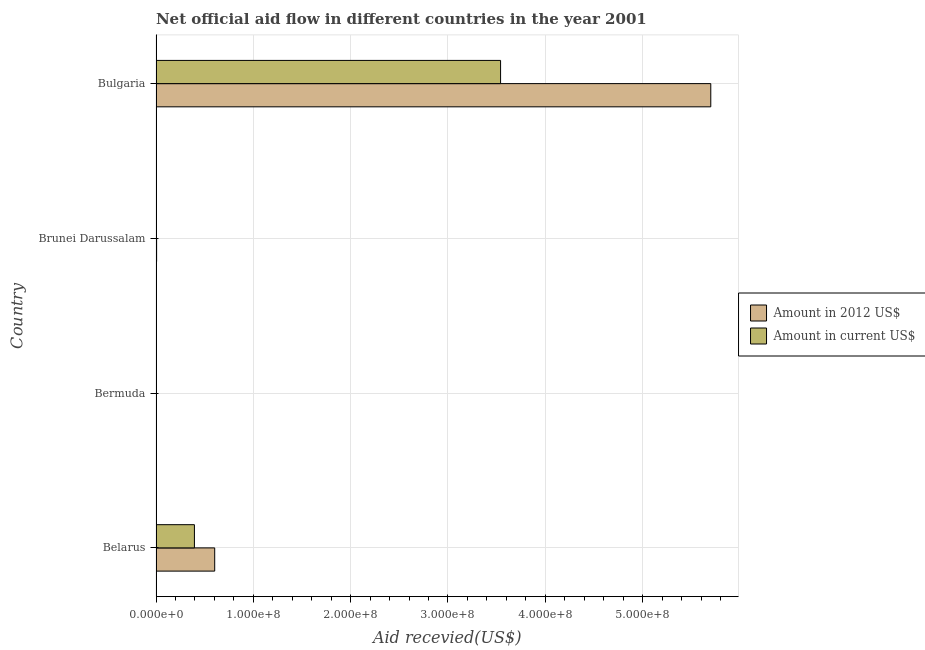How many different coloured bars are there?
Your response must be concise. 2. Are the number of bars per tick equal to the number of legend labels?
Make the answer very short. Yes. Are the number of bars on each tick of the Y-axis equal?
Offer a very short reply. Yes. How many bars are there on the 3rd tick from the top?
Your response must be concise. 2. How many bars are there on the 2nd tick from the bottom?
Ensure brevity in your answer.  2. What is the label of the 3rd group of bars from the top?
Your answer should be very brief. Bermuda. In how many cases, is the number of bars for a given country not equal to the number of legend labels?
Ensure brevity in your answer.  0. What is the amount of aid received(expressed in us$) in Brunei Darussalam?
Your answer should be compact. 3.50e+05. Across all countries, what is the maximum amount of aid received(expressed in 2012 us$)?
Ensure brevity in your answer.  5.70e+08. Across all countries, what is the minimum amount of aid received(expressed in 2012 us$)?
Give a very brief answer. 4.00e+04. In which country was the amount of aid received(expressed in us$) maximum?
Your response must be concise. Bulgaria. In which country was the amount of aid received(expressed in 2012 us$) minimum?
Offer a terse response. Bermuda. What is the total amount of aid received(expressed in us$) in the graph?
Provide a short and direct response. 3.94e+08. What is the difference between the amount of aid received(expressed in 2012 us$) in Bermuda and that in Brunei Darussalam?
Provide a short and direct response. -5.60e+05. What is the difference between the amount of aid received(expressed in us$) in Bermuda and the amount of aid received(expressed in 2012 us$) in Brunei Darussalam?
Make the answer very short. -5.80e+05. What is the average amount of aid received(expressed in 2012 us$) per country?
Make the answer very short. 1.58e+08. What is the difference between the amount of aid received(expressed in us$) and amount of aid received(expressed in 2012 us$) in Bermuda?
Provide a short and direct response. -2.00e+04. Is the amount of aid received(expressed in us$) in Bermuda less than that in Brunei Darussalam?
Ensure brevity in your answer.  Yes. Is the difference between the amount of aid received(expressed in us$) in Belarus and Bermuda greater than the difference between the amount of aid received(expressed in 2012 us$) in Belarus and Bermuda?
Keep it short and to the point. No. What is the difference between the highest and the second highest amount of aid received(expressed in us$)?
Your answer should be compact. 3.15e+08. What is the difference between the highest and the lowest amount of aid received(expressed in us$)?
Ensure brevity in your answer.  3.54e+08. In how many countries, is the amount of aid received(expressed in 2012 us$) greater than the average amount of aid received(expressed in 2012 us$) taken over all countries?
Give a very brief answer. 1. What does the 1st bar from the top in Belarus represents?
Ensure brevity in your answer.  Amount in current US$. What does the 2nd bar from the bottom in Brunei Darussalam represents?
Ensure brevity in your answer.  Amount in current US$. Are all the bars in the graph horizontal?
Offer a very short reply. Yes. What is the difference between two consecutive major ticks on the X-axis?
Your answer should be compact. 1.00e+08. Are the values on the major ticks of X-axis written in scientific E-notation?
Make the answer very short. Yes. Does the graph contain any zero values?
Offer a terse response. No. Where does the legend appear in the graph?
Ensure brevity in your answer.  Center right. How are the legend labels stacked?
Provide a succinct answer. Vertical. What is the title of the graph?
Your answer should be very brief. Net official aid flow in different countries in the year 2001. Does "Food and tobacco" appear as one of the legend labels in the graph?
Offer a very short reply. No. What is the label or title of the X-axis?
Your response must be concise. Aid recevied(US$). What is the label or title of the Y-axis?
Your answer should be compact. Country. What is the Aid recevied(US$) of Amount in 2012 US$ in Belarus?
Ensure brevity in your answer.  6.03e+07. What is the Aid recevied(US$) in Amount in current US$ in Belarus?
Offer a very short reply. 3.94e+07. What is the Aid recevied(US$) in Amount in current US$ in Bermuda?
Your answer should be very brief. 2.00e+04. What is the Aid recevied(US$) in Amount in 2012 US$ in Bulgaria?
Your answer should be very brief. 5.70e+08. What is the Aid recevied(US$) in Amount in current US$ in Bulgaria?
Provide a short and direct response. 3.54e+08. Across all countries, what is the maximum Aid recevied(US$) of Amount in 2012 US$?
Offer a terse response. 5.70e+08. Across all countries, what is the maximum Aid recevied(US$) in Amount in current US$?
Offer a terse response. 3.54e+08. What is the total Aid recevied(US$) of Amount in 2012 US$ in the graph?
Offer a very short reply. 6.31e+08. What is the total Aid recevied(US$) in Amount in current US$ in the graph?
Your response must be concise. 3.94e+08. What is the difference between the Aid recevied(US$) in Amount in 2012 US$ in Belarus and that in Bermuda?
Your answer should be compact. 6.02e+07. What is the difference between the Aid recevied(US$) of Amount in current US$ in Belarus and that in Bermuda?
Ensure brevity in your answer.  3.94e+07. What is the difference between the Aid recevied(US$) of Amount in 2012 US$ in Belarus and that in Brunei Darussalam?
Give a very brief answer. 5.97e+07. What is the difference between the Aid recevied(US$) of Amount in current US$ in Belarus and that in Brunei Darussalam?
Your answer should be very brief. 3.91e+07. What is the difference between the Aid recevied(US$) in Amount in 2012 US$ in Belarus and that in Bulgaria?
Provide a short and direct response. -5.10e+08. What is the difference between the Aid recevied(US$) in Amount in current US$ in Belarus and that in Bulgaria?
Provide a short and direct response. -3.15e+08. What is the difference between the Aid recevied(US$) in Amount in 2012 US$ in Bermuda and that in Brunei Darussalam?
Your answer should be very brief. -5.60e+05. What is the difference between the Aid recevied(US$) of Amount in current US$ in Bermuda and that in Brunei Darussalam?
Make the answer very short. -3.30e+05. What is the difference between the Aid recevied(US$) of Amount in 2012 US$ in Bermuda and that in Bulgaria?
Your answer should be compact. -5.70e+08. What is the difference between the Aid recevied(US$) of Amount in current US$ in Bermuda and that in Bulgaria?
Provide a short and direct response. -3.54e+08. What is the difference between the Aid recevied(US$) in Amount in 2012 US$ in Brunei Darussalam and that in Bulgaria?
Provide a succinct answer. -5.69e+08. What is the difference between the Aid recevied(US$) in Amount in current US$ in Brunei Darussalam and that in Bulgaria?
Ensure brevity in your answer.  -3.54e+08. What is the difference between the Aid recevied(US$) in Amount in 2012 US$ in Belarus and the Aid recevied(US$) in Amount in current US$ in Bermuda?
Give a very brief answer. 6.03e+07. What is the difference between the Aid recevied(US$) of Amount in 2012 US$ in Belarus and the Aid recevied(US$) of Amount in current US$ in Brunei Darussalam?
Your answer should be compact. 5.99e+07. What is the difference between the Aid recevied(US$) in Amount in 2012 US$ in Belarus and the Aid recevied(US$) in Amount in current US$ in Bulgaria?
Your answer should be compact. -2.94e+08. What is the difference between the Aid recevied(US$) of Amount in 2012 US$ in Bermuda and the Aid recevied(US$) of Amount in current US$ in Brunei Darussalam?
Make the answer very short. -3.10e+05. What is the difference between the Aid recevied(US$) in Amount in 2012 US$ in Bermuda and the Aid recevied(US$) in Amount in current US$ in Bulgaria?
Your response must be concise. -3.54e+08. What is the difference between the Aid recevied(US$) in Amount in 2012 US$ in Brunei Darussalam and the Aid recevied(US$) in Amount in current US$ in Bulgaria?
Keep it short and to the point. -3.53e+08. What is the average Aid recevied(US$) in Amount in 2012 US$ per country?
Make the answer very short. 1.58e+08. What is the average Aid recevied(US$) in Amount in current US$ per country?
Offer a terse response. 9.85e+07. What is the difference between the Aid recevied(US$) of Amount in 2012 US$ and Aid recevied(US$) of Amount in current US$ in Belarus?
Provide a succinct answer. 2.08e+07. What is the difference between the Aid recevied(US$) in Amount in 2012 US$ and Aid recevied(US$) in Amount in current US$ in Bermuda?
Offer a very short reply. 2.00e+04. What is the difference between the Aid recevied(US$) in Amount in 2012 US$ and Aid recevied(US$) in Amount in current US$ in Bulgaria?
Your response must be concise. 2.16e+08. What is the ratio of the Aid recevied(US$) in Amount in 2012 US$ in Belarus to that in Bermuda?
Provide a short and direct response. 1507.25. What is the ratio of the Aid recevied(US$) in Amount in current US$ in Belarus to that in Bermuda?
Your response must be concise. 1972.5. What is the ratio of the Aid recevied(US$) of Amount in 2012 US$ in Belarus to that in Brunei Darussalam?
Your answer should be compact. 100.48. What is the ratio of the Aid recevied(US$) in Amount in current US$ in Belarus to that in Brunei Darussalam?
Make the answer very short. 112.71. What is the ratio of the Aid recevied(US$) of Amount in 2012 US$ in Belarus to that in Bulgaria?
Provide a succinct answer. 0.11. What is the ratio of the Aid recevied(US$) in Amount in current US$ in Belarus to that in Bulgaria?
Keep it short and to the point. 0.11. What is the ratio of the Aid recevied(US$) in Amount in 2012 US$ in Bermuda to that in Brunei Darussalam?
Ensure brevity in your answer.  0.07. What is the ratio of the Aid recevied(US$) of Amount in current US$ in Bermuda to that in Brunei Darussalam?
Provide a short and direct response. 0.06. What is the ratio of the Aid recevied(US$) in Amount in 2012 US$ in Bermuda to that in Bulgaria?
Provide a succinct answer. 0. What is the ratio of the Aid recevied(US$) of Amount in 2012 US$ in Brunei Darussalam to that in Bulgaria?
Your answer should be compact. 0. What is the ratio of the Aid recevied(US$) of Amount in current US$ in Brunei Darussalam to that in Bulgaria?
Make the answer very short. 0. What is the difference between the highest and the second highest Aid recevied(US$) in Amount in 2012 US$?
Provide a short and direct response. 5.10e+08. What is the difference between the highest and the second highest Aid recevied(US$) of Amount in current US$?
Provide a succinct answer. 3.15e+08. What is the difference between the highest and the lowest Aid recevied(US$) in Amount in 2012 US$?
Offer a very short reply. 5.70e+08. What is the difference between the highest and the lowest Aid recevied(US$) of Amount in current US$?
Your answer should be compact. 3.54e+08. 